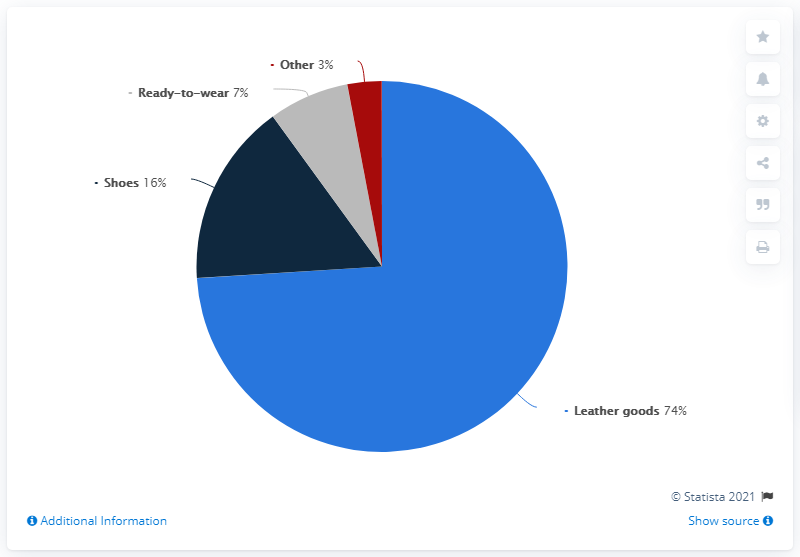Draw attention to some important aspects in this diagram. The sum of ready-to-wear and shoes is 23. It is clear that leather goods have the greatest share of revenue compared to the other product categories. 